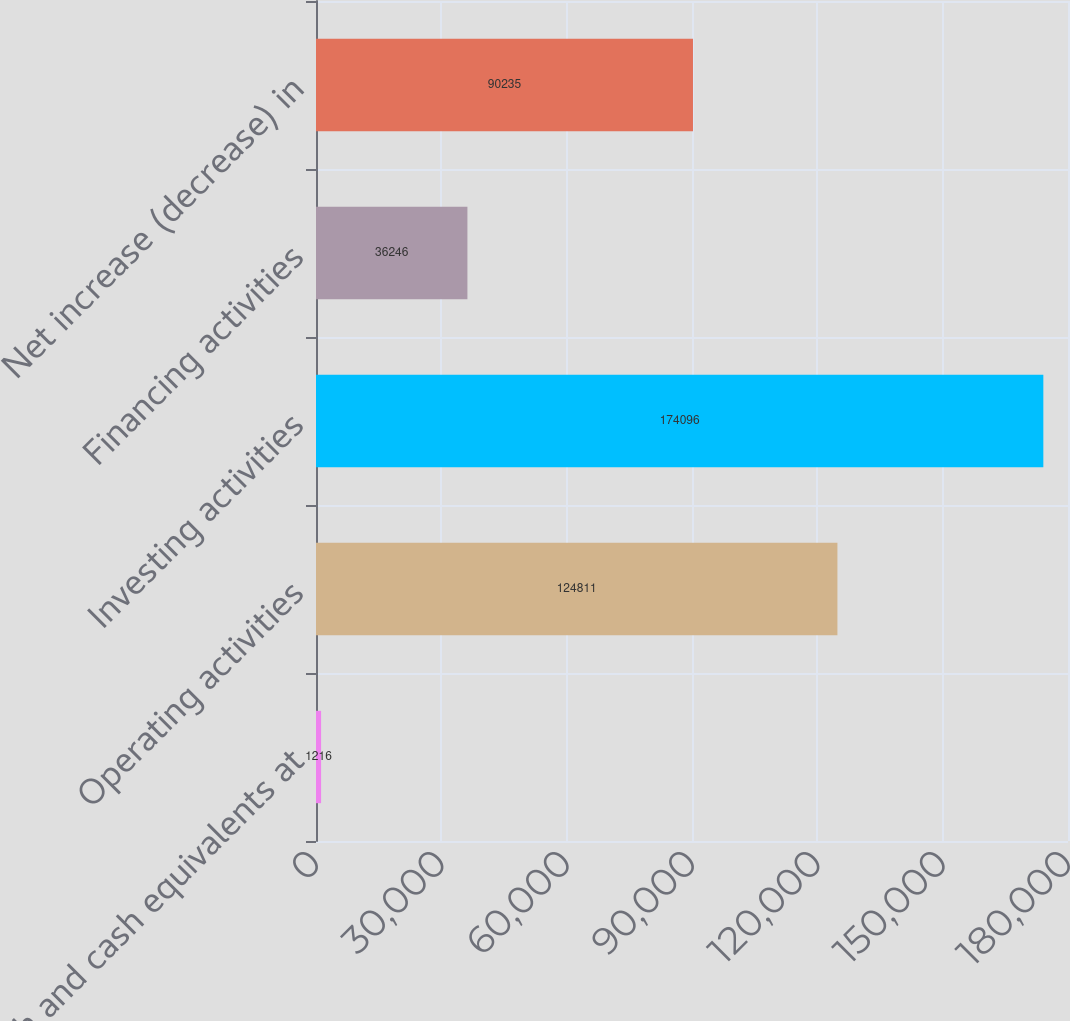<chart> <loc_0><loc_0><loc_500><loc_500><bar_chart><fcel>Cash and cash equivalents at<fcel>Operating activities<fcel>Investing activities<fcel>Financing activities<fcel>Net increase (decrease) in<nl><fcel>1216<fcel>124811<fcel>174096<fcel>36246<fcel>90235<nl></chart> 